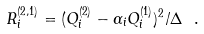<formula> <loc_0><loc_0><loc_500><loc_500>R _ { i } ^ { ( 2 , 1 ) } = ( Q _ { i } ^ { ( 2 ) } - \alpha _ { i } Q _ { i } ^ { ( 1 ) } ) ^ { 2 } / \Delta \ .</formula> 